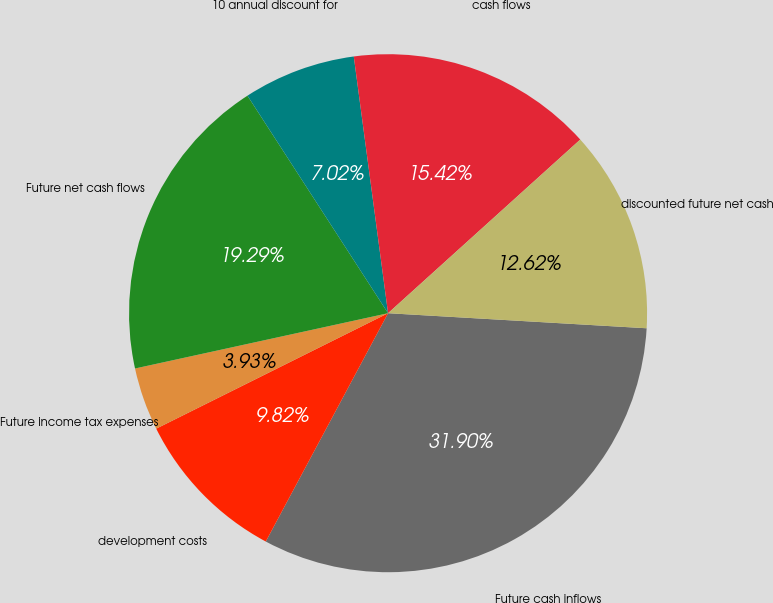Convert chart. <chart><loc_0><loc_0><loc_500><loc_500><pie_chart><fcel>Future cash inflows<fcel>development costs<fcel>Future income tax expenses<fcel>Future net cash flows<fcel>10 annual discount for<fcel>cash flows<fcel>discounted future net cash<nl><fcel>31.9%<fcel>9.82%<fcel>3.93%<fcel>19.29%<fcel>7.02%<fcel>15.42%<fcel>12.62%<nl></chart> 